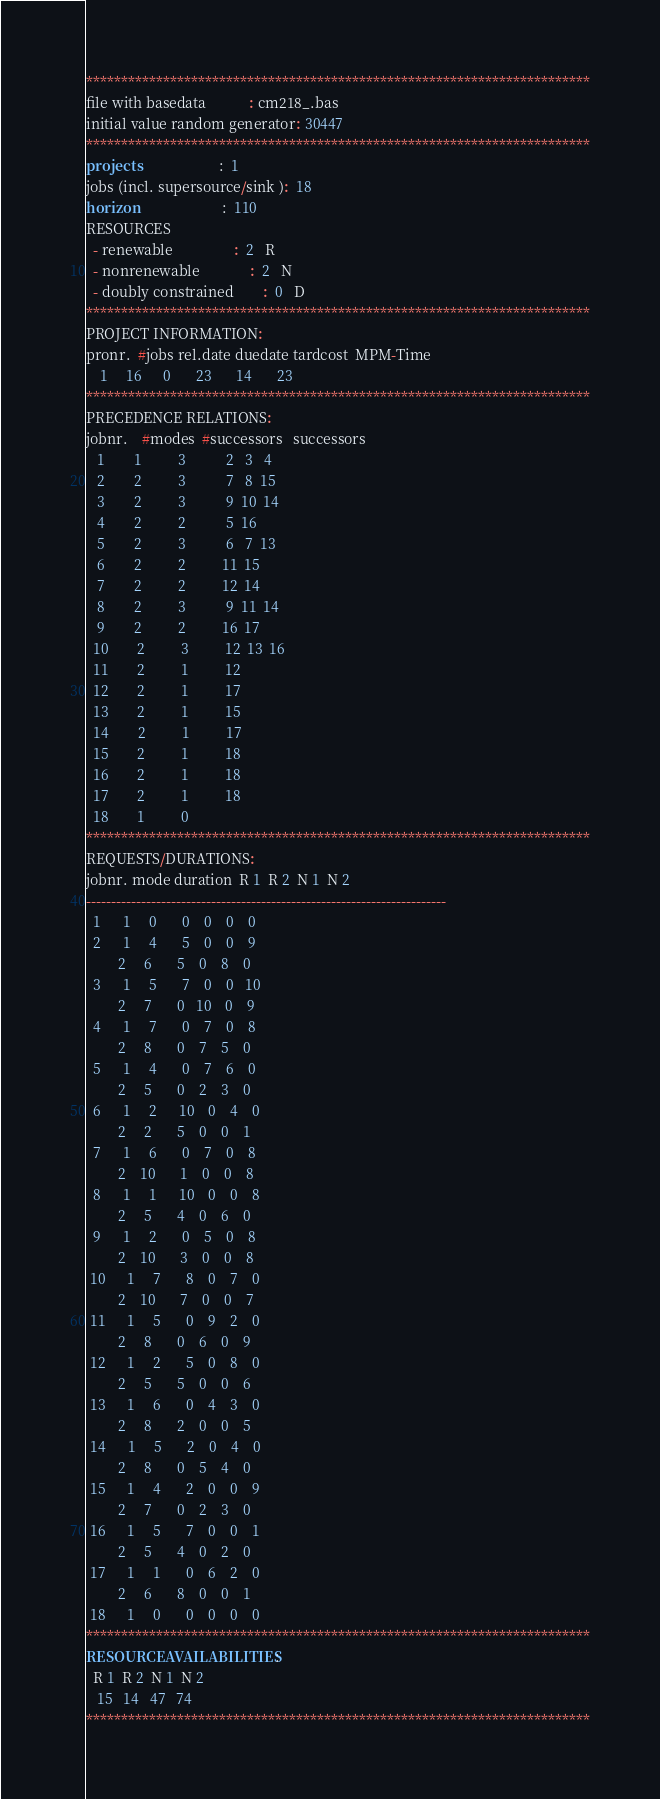<code> <loc_0><loc_0><loc_500><loc_500><_ObjectiveC_>************************************************************************
file with basedata            : cm218_.bas
initial value random generator: 30447
************************************************************************
projects                      :  1
jobs (incl. supersource/sink ):  18
horizon                       :  110
RESOURCES
  - renewable                 :  2   R
  - nonrenewable              :  2   N
  - doubly constrained        :  0   D
************************************************************************
PROJECT INFORMATION:
pronr.  #jobs rel.date duedate tardcost  MPM-Time
    1     16      0       23       14       23
************************************************************************
PRECEDENCE RELATIONS:
jobnr.    #modes  #successors   successors
   1        1          3           2   3   4
   2        2          3           7   8  15
   3        2          3           9  10  14
   4        2          2           5  16
   5        2          3           6   7  13
   6        2          2          11  15
   7        2          2          12  14
   8        2          3           9  11  14
   9        2          2          16  17
  10        2          3          12  13  16
  11        2          1          12
  12        2          1          17
  13        2          1          15
  14        2          1          17
  15        2          1          18
  16        2          1          18
  17        2          1          18
  18        1          0        
************************************************************************
REQUESTS/DURATIONS:
jobnr. mode duration  R 1  R 2  N 1  N 2
------------------------------------------------------------------------
  1      1     0       0    0    0    0
  2      1     4       5    0    0    9
         2     6       5    0    8    0
  3      1     5       7    0    0   10
         2     7       0   10    0    9
  4      1     7       0    7    0    8
         2     8       0    7    5    0
  5      1     4       0    7    6    0
         2     5       0    2    3    0
  6      1     2      10    0    4    0
         2     2       5    0    0    1
  7      1     6       0    7    0    8
         2    10       1    0    0    8
  8      1     1      10    0    0    8
         2     5       4    0    6    0
  9      1     2       0    5    0    8
         2    10       3    0    0    8
 10      1     7       8    0    7    0
         2    10       7    0    0    7
 11      1     5       0    9    2    0
         2     8       0    6    0    9
 12      1     2       5    0    8    0
         2     5       5    0    0    6
 13      1     6       0    4    3    0
         2     8       2    0    0    5
 14      1     5       2    0    4    0
         2     8       0    5    4    0
 15      1     4       2    0    0    9
         2     7       0    2    3    0
 16      1     5       7    0    0    1
         2     5       4    0    2    0
 17      1     1       0    6    2    0
         2     6       8    0    0    1
 18      1     0       0    0    0    0
************************************************************************
RESOURCEAVAILABILITIES:
  R 1  R 2  N 1  N 2
   15   14   47   74
************************************************************************
</code> 